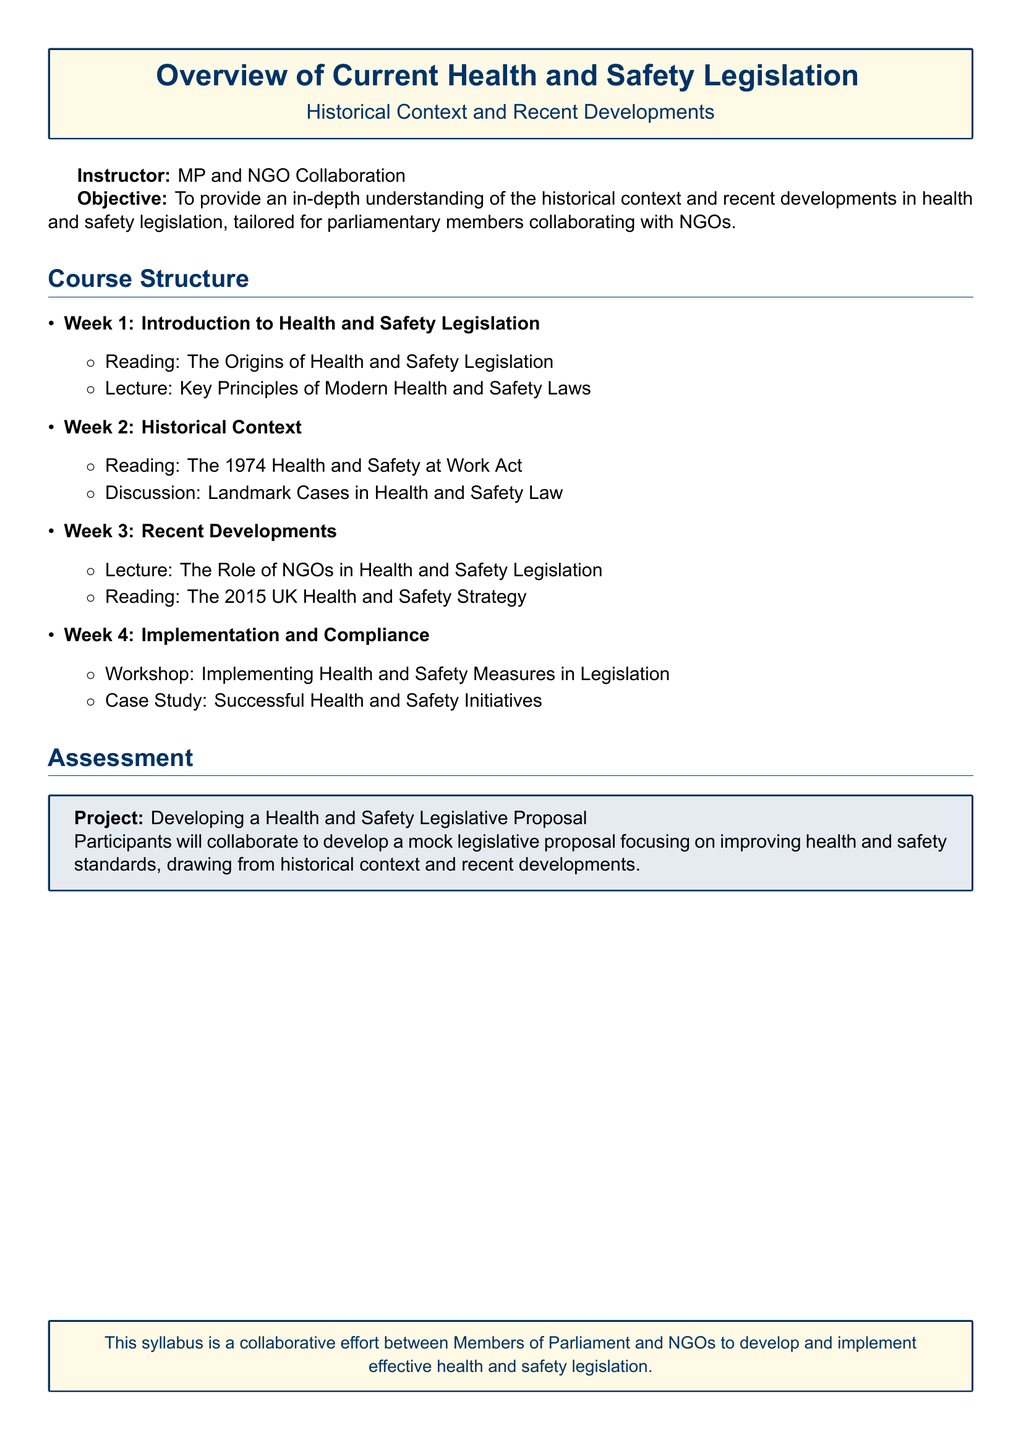What is the title of the syllabus? The title is prominently displayed at the top of the syllabus, indicating the main focus on health and safety legislation.
Answer: Overview of Current Health and Safety Legislation Who is the instructor for the course? The instructor's name is mentioned in the document, indicating their role in presenting the content.
Answer: MP and NGO Collaboration What is the objective of the course? The objective is outlined at the beginning of the syllabus, summarizing the intended outcome of the course.
Answer: To provide an in-depth understanding of the historical context and recent developments in health and safety legislation What is covered in Week 2? The document specifies the readings and discussions planned for Week 2 related to historical context.
Answer: The 1974 Health and Safety at Work Act How many weeks does the course structure last? The syllabus lists the number of weeks dedicated to various topics, indicating the duration of the course.
Answer: 4 weeks What type of project will participants undertake? The assessment section describes the nature of the project participants will be working on.
Answer: Developing a Health and Safety Legislative Proposal What is highlighted in Week 3's lecture? The syllabus outlines key topics for each week, indicating a focus during Week 3 discussions.
Answer: The Role of NGOs in Health and Safety Legislation What type of activity is planned for Week 4? The syllabus specifies the format of the activities planned for the final week of the course.
Answer: Workshop What are the key readings for Week 1? The specific readings for Week 1 are mentioned in the syllabus, providing insight into foundational knowledge.
Answer: The Origins of Health and Safety Legislation 